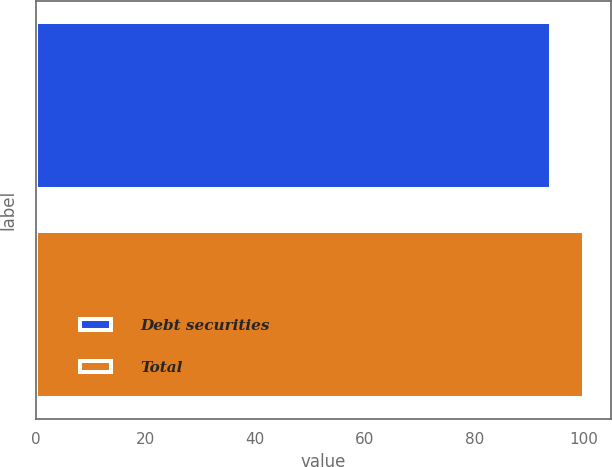Convert chart. <chart><loc_0><loc_0><loc_500><loc_500><bar_chart><fcel>Debt securities<fcel>Total<nl><fcel>94<fcel>100<nl></chart> 